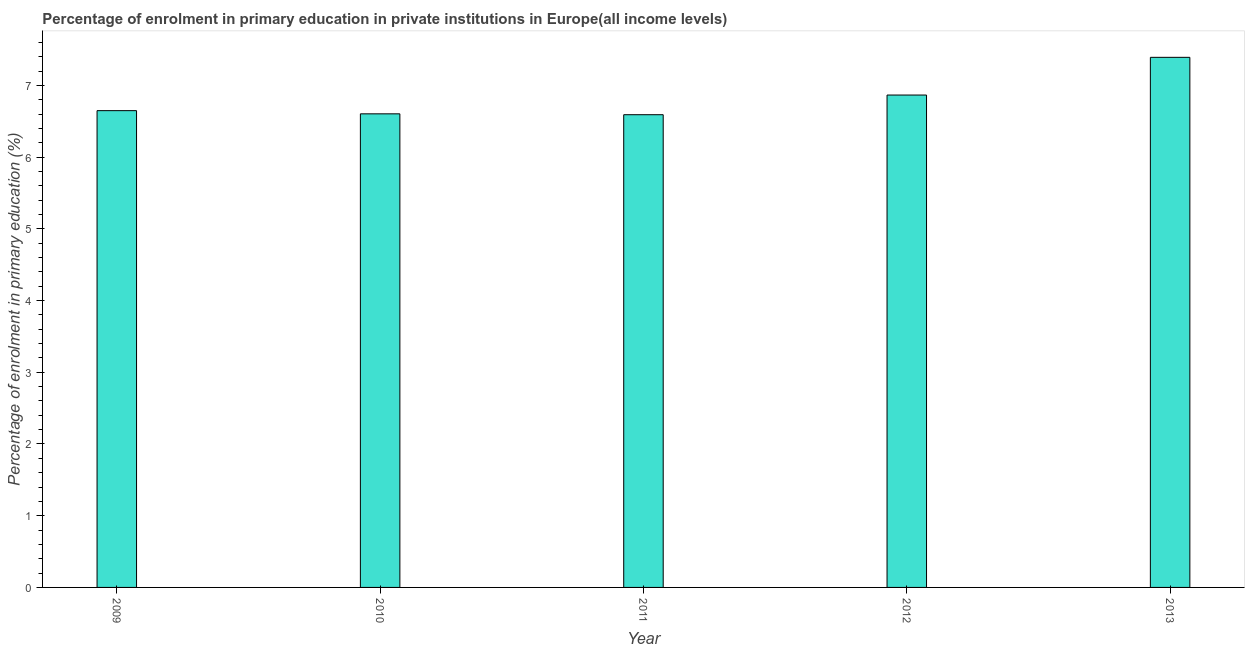Does the graph contain any zero values?
Keep it short and to the point. No. What is the title of the graph?
Make the answer very short. Percentage of enrolment in primary education in private institutions in Europe(all income levels). What is the label or title of the X-axis?
Keep it short and to the point. Year. What is the label or title of the Y-axis?
Make the answer very short. Percentage of enrolment in primary education (%). What is the enrolment percentage in primary education in 2009?
Offer a terse response. 6.65. Across all years, what is the maximum enrolment percentage in primary education?
Provide a short and direct response. 7.39. Across all years, what is the minimum enrolment percentage in primary education?
Provide a succinct answer. 6.59. In which year was the enrolment percentage in primary education maximum?
Your response must be concise. 2013. In which year was the enrolment percentage in primary education minimum?
Offer a very short reply. 2011. What is the sum of the enrolment percentage in primary education?
Your answer should be compact. 34.1. What is the average enrolment percentage in primary education per year?
Your answer should be compact. 6.82. What is the median enrolment percentage in primary education?
Ensure brevity in your answer.  6.65. In how many years, is the enrolment percentage in primary education greater than 5.8 %?
Your response must be concise. 5. What is the ratio of the enrolment percentage in primary education in 2009 to that in 2011?
Give a very brief answer. 1.01. What is the difference between the highest and the second highest enrolment percentage in primary education?
Ensure brevity in your answer.  0.53. Is the sum of the enrolment percentage in primary education in 2010 and 2011 greater than the maximum enrolment percentage in primary education across all years?
Provide a short and direct response. Yes. In how many years, is the enrolment percentage in primary education greater than the average enrolment percentage in primary education taken over all years?
Keep it short and to the point. 2. Are all the bars in the graph horizontal?
Your answer should be compact. No. How many years are there in the graph?
Provide a succinct answer. 5. What is the difference between two consecutive major ticks on the Y-axis?
Your answer should be very brief. 1. What is the Percentage of enrolment in primary education (%) in 2009?
Offer a terse response. 6.65. What is the Percentage of enrolment in primary education (%) of 2010?
Ensure brevity in your answer.  6.6. What is the Percentage of enrolment in primary education (%) of 2011?
Offer a terse response. 6.59. What is the Percentage of enrolment in primary education (%) in 2012?
Make the answer very short. 6.86. What is the Percentage of enrolment in primary education (%) of 2013?
Keep it short and to the point. 7.39. What is the difference between the Percentage of enrolment in primary education (%) in 2009 and 2010?
Give a very brief answer. 0.04. What is the difference between the Percentage of enrolment in primary education (%) in 2009 and 2011?
Ensure brevity in your answer.  0.06. What is the difference between the Percentage of enrolment in primary education (%) in 2009 and 2012?
Give a very brief answer. -0.22. What is the difference between the Percentage of enrolment in primary education (%) in 2009 and 2013?
Give a very brief answer. -0.74. What is the difference between the Percentage of enrolment in primary education (%) in 2010 and 2011?
Provide a succinct answer. 0.01. What is the difference between the Percentage of enrolment in primary education (%) in 2010 and 2012?
Give a very brief answer. -0.26. What is the difference between the Percentage of enrolment in primary education (%) in 2010 and 2013?
Offer a terse response. -0.79. What is the difference between the Percentage of enrolment in primary education (%) in 2011 and 2012?
Offer a very short reply. -0.27. What is the difference between the Percentage of enrolment in primary education (%) in 2011 and 2013?
Your response must be concise. -0.8. What is the difference between the Percentage of enrolment in primary education (%) in 2012 and 2013?
Your answer should be compact. -0.53. What is the ratio of the Percentage of enrolment in primary education (%) in 2009 to that in 2012?
Your response must be concise. 0.97. What is the ratio of the Percentage of enrolment in primary education (%) in 2009 to that in 2013?
Give a very brief answer. 0.9. What is the ratio of the Percentage of enrolment in primary education (%) in 2010 to that in 2013?
Offer a terse response. 0.89. What is the ratio of the Percentage of enrolment in primary education (%) in 2011 to that in 2013?
Ensure brevity in your answer.  0.89. What is the ratio of the Percentage of enrolment in primary education (%) in 2012 to that in 2013?
Offer a terse response. 0.93. 